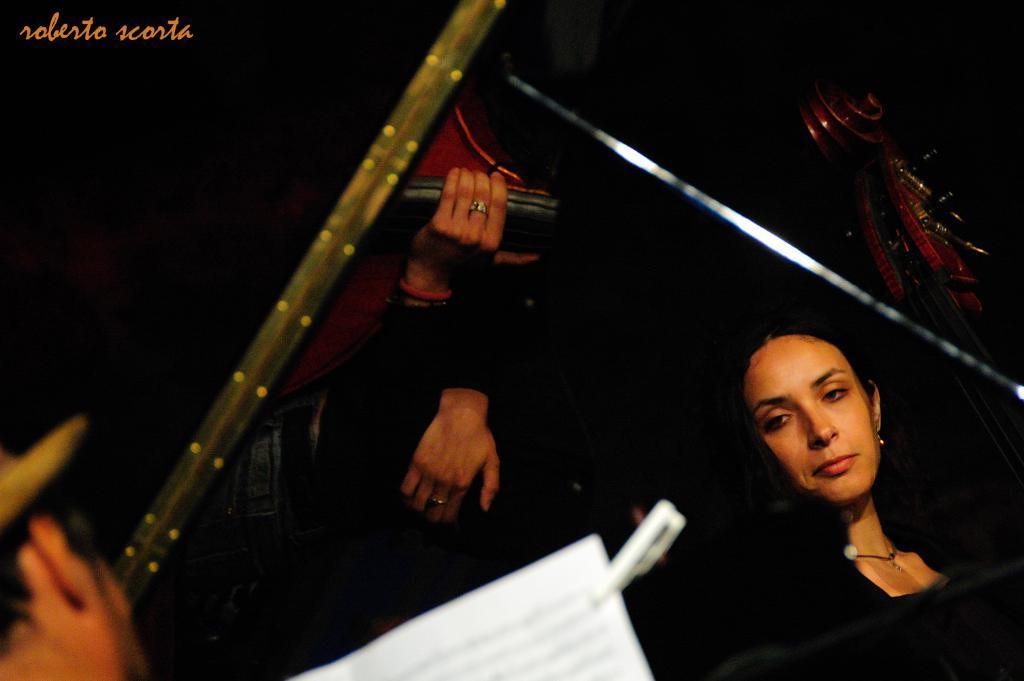Please provide a concise description of this image. In the right bottom of the picture, the woman in black T-shirt is smiling. Beside her, we see the hands of the person. At the bottom of the picture, we see a paper which is white in color. In the background, it is black in color. This picture is clicked in the dark. 